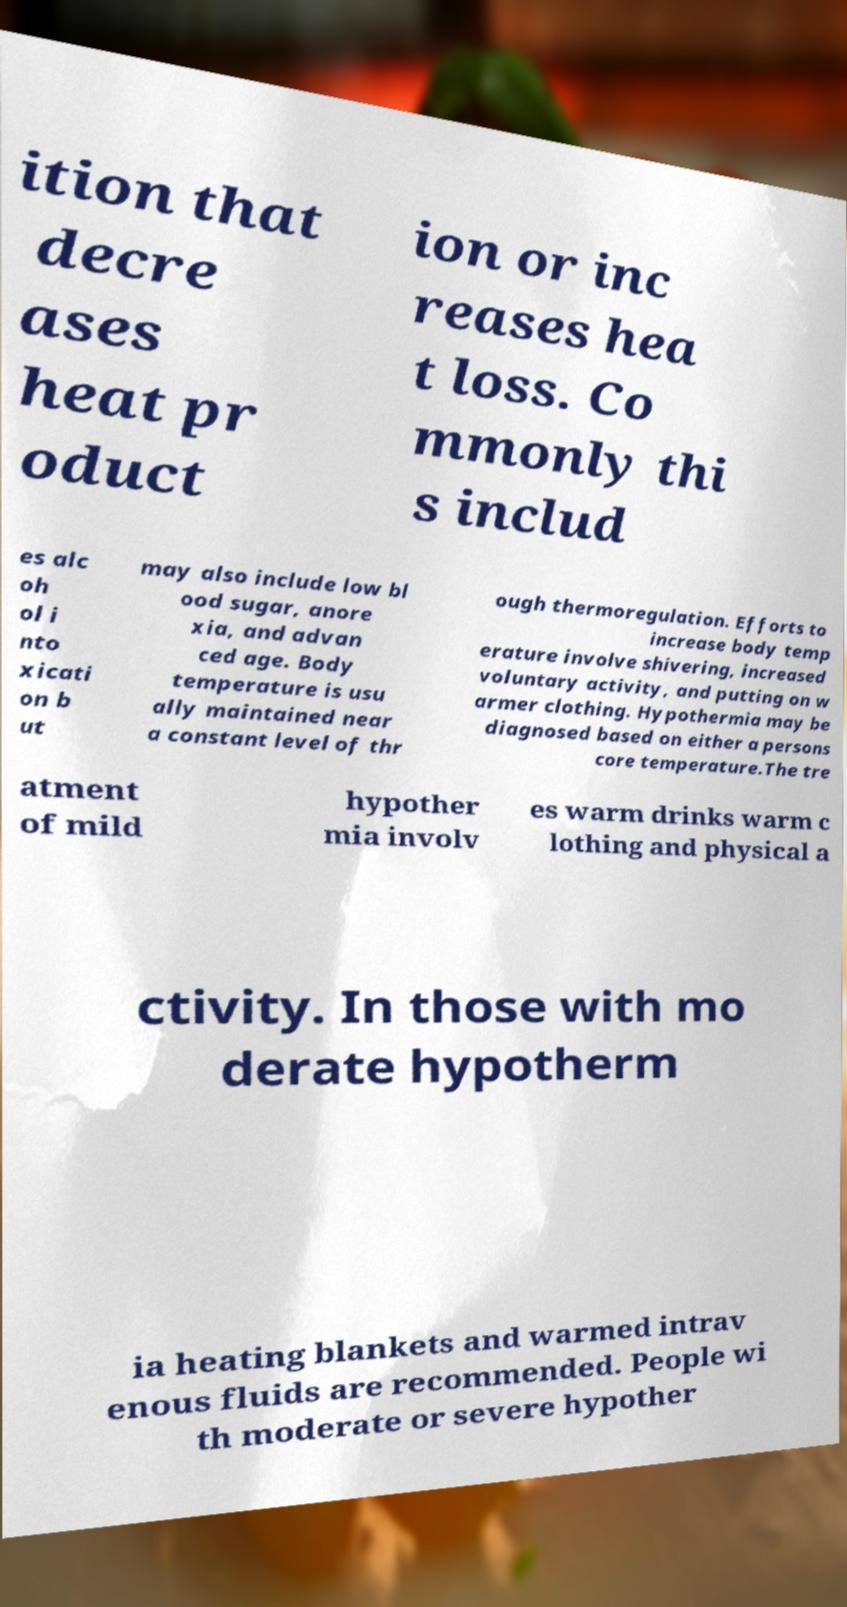I need the written content from this picture converted into text. Can you do that? ition that decre ases heat pr oduct ion or inc reases hea t loss. Co mmonly thi s includ es alc oh ol i nto xicati on b ut may also include low bl ood sugar, anore xia, and advan ced age. Body temperature is usu ally maintained near a constant level of thr ough thermoregulation. Efforts to increase body temp erature involve shivering, increased voluntary activity, and putting on w armer clothing. Hypothermia may be diagnosed based on either a persons core temperature.The tre atment of mild hypother mia involv es warm drinks warm c lothing and physical a ctivity. In those with mo derate hypotherm ia heating blankets and warmed intrav enous fluids are recommended. People wi th moderate or severe hypother 